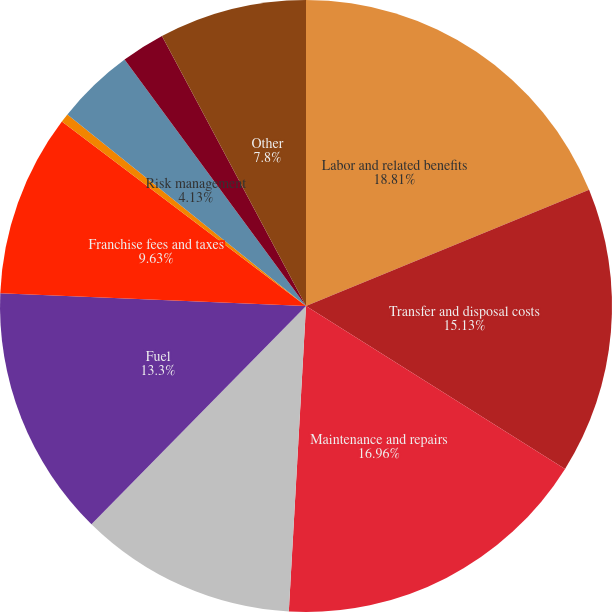Convert chart. <chart><loc_0><loc_0><loc_500><loc_500><pie_chart><fcel>Labor and related benefits<fcel>Transfer and disposal costs<fcel>Maintenance and repairs<fcel>Transportation and subcontract<fcel>Fuel<fcel>Franchise fees and taxes<fcel>Landfill operating costs<fcel>Risk management<fcel>Cost of goods sold<fcel>Other<nl><fcel>18.8%<fcel>15.13%<fcel>16.96%<fcel>11.47%<fcel>13.3%<fcel>9.63%<fcel>0.47%<fcel>4.13%<fcel>2.3%<fcel>7.8%<nl></chart> 